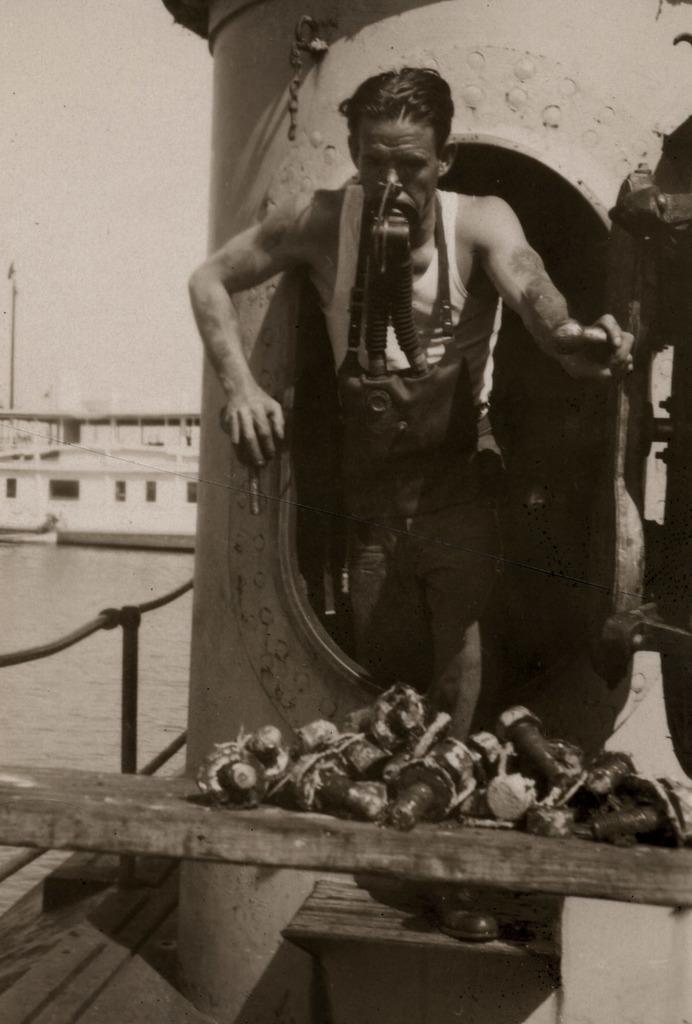In one or two sentences, can you explain what this image depicts? In the foreground of the picture we can see a person in a boat and there are various objects on a wooden table. On the left we can see a water body and a building. At the top left corner there is sky. 